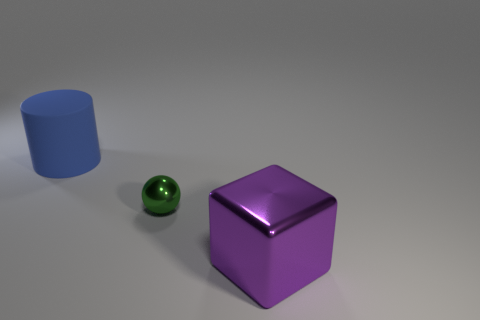Add 1 purple blocks. How many objects exist? 4 Subtract all spheres. How many objects are left? 2 Subtract all large purple things. Subtract all green shiny things. How many objects are left? 1 Add 1 metallic things. How many metallic things are left? 3 Add 2 small green shiny things. How many small green shiny things exist? 3 Subtract 1 blue cylinders. How many objects are left? 2 